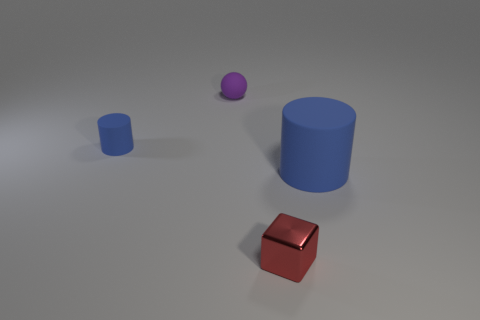Are there more large brown rubber cubes than small rubber spheres? In the image, there appears to be just one large brown rubber cube and one small rubber sphere, so the number of large brown rubber cubes is equal to the number of small rubber spheres. 